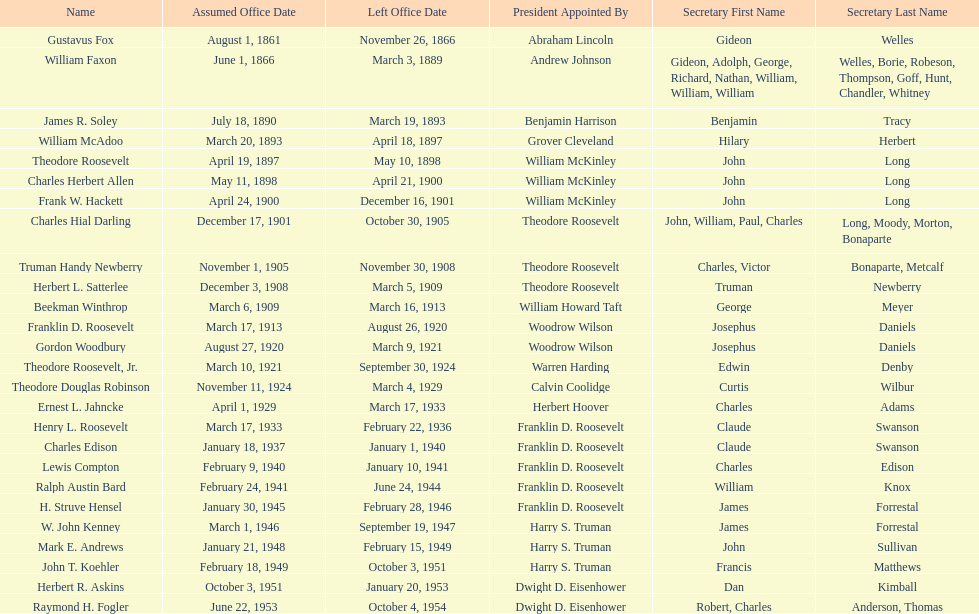Who was the first assistant secretary of the navy? Gustavus Fox. Could you parse the entire table? {'header': ['Name', 'Assumed Office Date', 'Left Office Date', 'President Appointed By', 'Secretary First Name', 'Secretary Last Name'], 'rows': [['Gustavus Fox', 'August 1, 1861', 'November 26, 1866', 'Abraham Lincoln', 'Gideon', 'Welles'], ['William Faxon', 'June 1, 1866', 'March 3, 1889', 'Andrew Johnson', 'Gideon, Adolph, George, Richard, Nathan, William, William, William', 'Welles, Borie, Robeson, Thompson, Goff, Hunt, Chandler, Whitney'], ['James R. Soley', 'July 18, 1890', 'March 19, 1893', 'Benjamin Harrison', 'Benjamin', 'Tracy'], ['William McAdoo', 'March 20, 1893', 'April 18, 1897', 'Grover Cleveland', 'Hilary', 'Herbert'], ['Theodore Roosevelt', 'April 19, 1897', 'May 10, 1898', 'William McKinley', 'John', 'Long'], ['Charles Herbert Allen', 'May 11, 1898', 'April 21, 1900', 'William McKinley', 'John', 'Long'], ['Frank W. Hackett', 'April 24, 1900', 'December 16, 1901', 'William McKinley', 'John', 'Long'], ['Charles Hial Darling', 'December 17, 1901', 'October 30, 1905', 'Theodore Roosevelt', 'John, William, Paul, Charles', 'Long, Moody, Morton, Bonaparte'], ['Truman Handy Newberry', 'November 1, 1905', 'November 30, 1908', 'Theodore Roosevelt', 'Charles, Victor', 'Bonaparte, Metcalf'], ['Herbert L. Satterlee', 'December 3, 1908', 'March 5, 1909', 'Theodore Roosevelt', 'Truman', 'Newberry'], ['Beekman Winthrop', 'March 6, 1909', 'March 16, 1913', 'William Howard Taft', 'George', 'Meyer'], ['Franklin D. Roosevelt', 'March 17, 1913', 'August 26, 1920', 'Woodrow Wilson', 'Josephus', 'Daniels'], ['Gordon Woodbury', 'August 27, 1920', 'March 9, 1921', 'Woodrow Wilson', 'Josephus', 'Daniels'], ['Theodore Roosevelt, Jr.', 'March 10, 1921', 'September 30, 1924', 'Warren Harding', 'Edwin', 'Denby'], ['Theodore Douglas Robinson', 'November 11, 1924', 'March 4, 1929', 'Calvin Coolidge', 'Curtis', 'Wilbur'], ['Ernest L. Jahncke', 'April 1, 1929', 'March 17, 1933', 'Herbert Hoover', 'Charles', 'Adams'], ['Henry L. Roosevelt', 'March 17, 1933', 'February 22, 1936', 'Franklin D. Roosevelt', 'Claude', 'Swanson'], ['Charles Edison', 'January 18, 1937', 'January 1, 1940', 'Franklin D. Roosevelt', 'Claude', 'Swanson'], ['Lewis Compton', 'February 9, 1940', 'January 10, 1941', 'Franklin D. Roosevelt', 'Charles', 'Edison'], ['Ralph Austin Bard', 'February 24, 1941', 'June 24, 1944', 'Franklin D. Roosevelt', 'William', 'Knox'], ['H. Struve Hensel', 'January 30, 1945', 'February 28, 1946', 'Franklin D. Roosevelt', 'James', 'Forrestal'], ['W. John Kenney', 'March 1, 1946', 'September 19, 1947', 'Harry S. Truman', 'James', 'Forrestal'], ['Mark E. Andrews', 'January 21, 1948', 'February 15, 1949', 'Harry S. Truman', 'John', 'Sullivan'], ['John T. Koehler', 'February 18, 1949', 'October 3, 1951', 'Harry S. Truman', 'Francis', 'Matthews'], ['Herbert R. Askins', 'October 3, 1951', 'January 20, 1953', 'Dwight D. Eisenhower', 'Dan', 'Kimball'], ['Raymond H. Fogler', 'June 22, 1953', 'October 4, 1954', 'Dwight D. Eisenhower', 'Robert, Charles', 'Anderson, Thomas']]} 